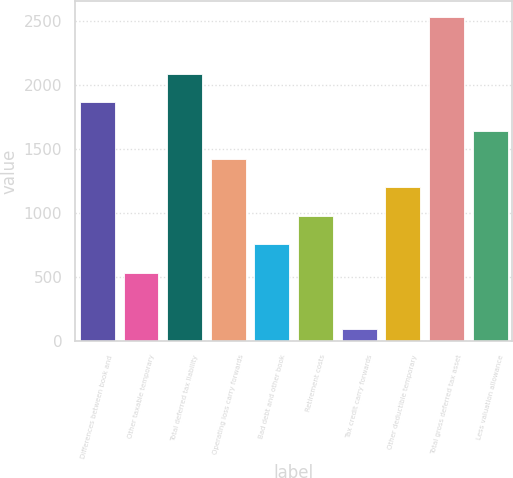Convert chart to OTSL. <chart><loc_0><loc_0><loc_500><loc_500><bar_chart><fcel>Differences between book and<fcel>Other taxable temporary<fcel>Total deferred tax liability<fcel>Operating loss carry forwards<fcel>Bad debt and other book<fcel>Retirement costs<fcel>Tax credit carry forwards<fcel>Other deductible temporary<fcel>Total gross deferred tax asset<fcel>Less valuation allowance<nl><fcel>1866.2<fcel>534.8<fcel>2088.1<fcel>1422.4<fcel>756.7<fcel>978.6<fcel>91<fcel>1200.5<fcel>2531.9<fcel>1644.3<nl></chart> 